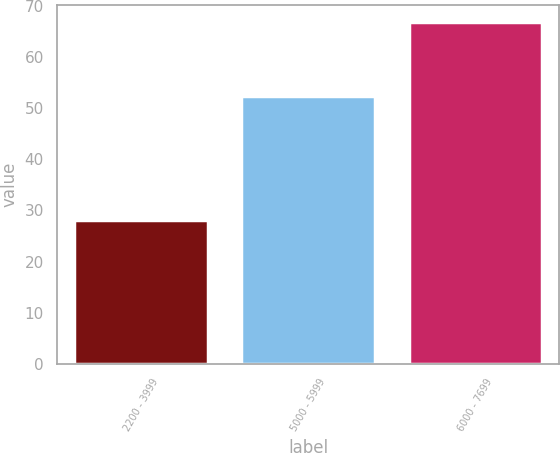Convert chart to OTSL. <chart><loc_0><loc_0><loc_500><loc_500><bar_chart><fcel>2200 - 3999<fcel>5000 - 5999<fcel>6000 - 7699<nl><fcel>28.13<fcel>52.43<fcel>66.75<nl></chart> 